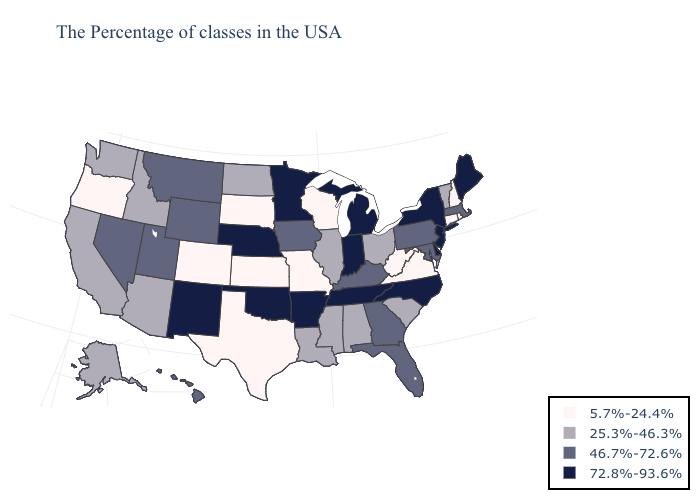Does Delaware have the lowest value in the USA?
Be succinct. No. Name the states that have a value in the range 72.8%-93.6%?
Give a very brief answer. Maine, New York, New Jersey, Delaware, North Carolina, Michigan, Indiana, Tennessee, Arkansas, Minnesota, Nebraska, Oklahoma, New Mexico. What is the highest value in states that border Louisiana?
Keep it brief. 72.8%-93.6%. What is the lowest value in the South?
Concise answer only. 5.7%-24.4%. Name the states that have a value in the range 46.7%-72.6%?
Short answer required. Massachusetts, Maryland, Pennsylvania, Florida, Georgia, Kentucky, Iowa, Wyoming, Utah, Montana, Nevada, Hawaii. What is the lowest value in states that border Maryland?
Short answer required. 5.7%-24.4%. Name the states that have a value in the range 72.8%-93.6%?
Answer briefly. Maine, New York, New Jersey, Delaware, North Carolina, Michigan, Indiana, Tennessee, Arkansas, Minnesota, Nebraska, Oklahoma, New Mexico. Does South Dakota have a lower value than Missouri?
Quick response, please. No. What is the value of Arizona?
Short answer required. 25.3%-46.3%. Does Mississippi have the highest value in the South?
Write a very short answer. No. How many symbols are there in the legend?
Quick response, please. 4. Does Indiana have the highest value in the USA?
Keep it brief. Yes. What is the value of Ohio?
Be succinct. 25.3%-46.3%. Name the states that have a value in the range 46.7%-72.6%?
Short answer required. Massachusetts, Maryland, Pennsylvania, Florida, Georgia, Kentucky, Iowa, Wyoming, Utah, Montana, Nevada, Hawaii. Name the states that have a value in the range 25.3%-46.3%?
Be succinct. Vermont, South Carolina, Ohio, Alabama, Illinois, Mississippi, Louisiana, North Dakota, Arizona, Idaho, California, Washington, Alaska. 